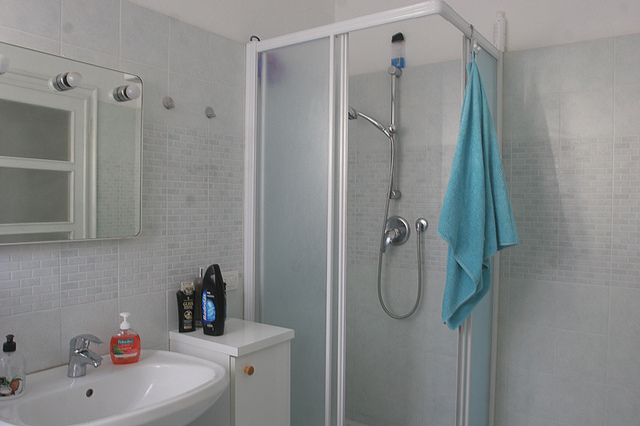What is the aqua item hanging next to the shower?
Answer the question using a single word or phrase. Towel 